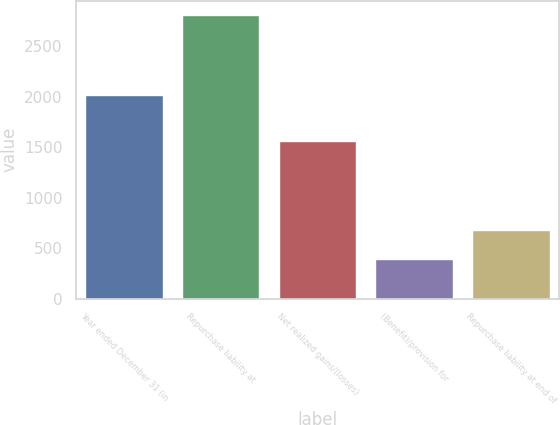<chart> <loc_0><loc_0><loc_500><loc_500><bar_chart><fcel>Year ended December 31 (in<fcel>Repurchase liability at<fcel>Net realized gains/(losses)<fcel>(Benefit)/provision for<fcel>Repurchase liability at end of<nl><fcel>2013<fcel>2811<fcel>1561<fcel>390<fcel>681<nl></chart> 